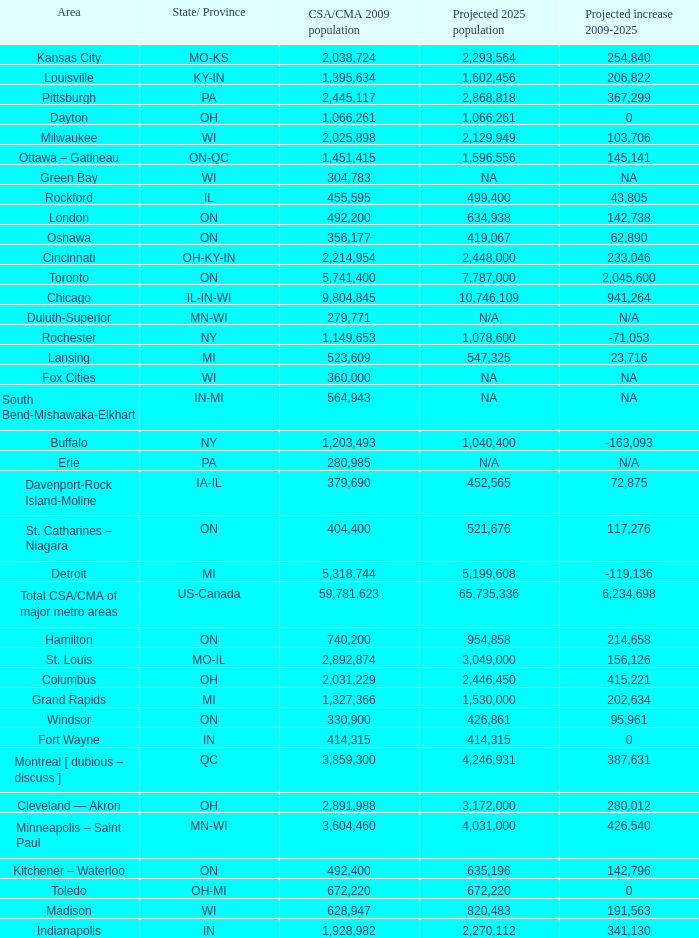What's the CSA/CMA Population in IA-IL? 379690.0. 